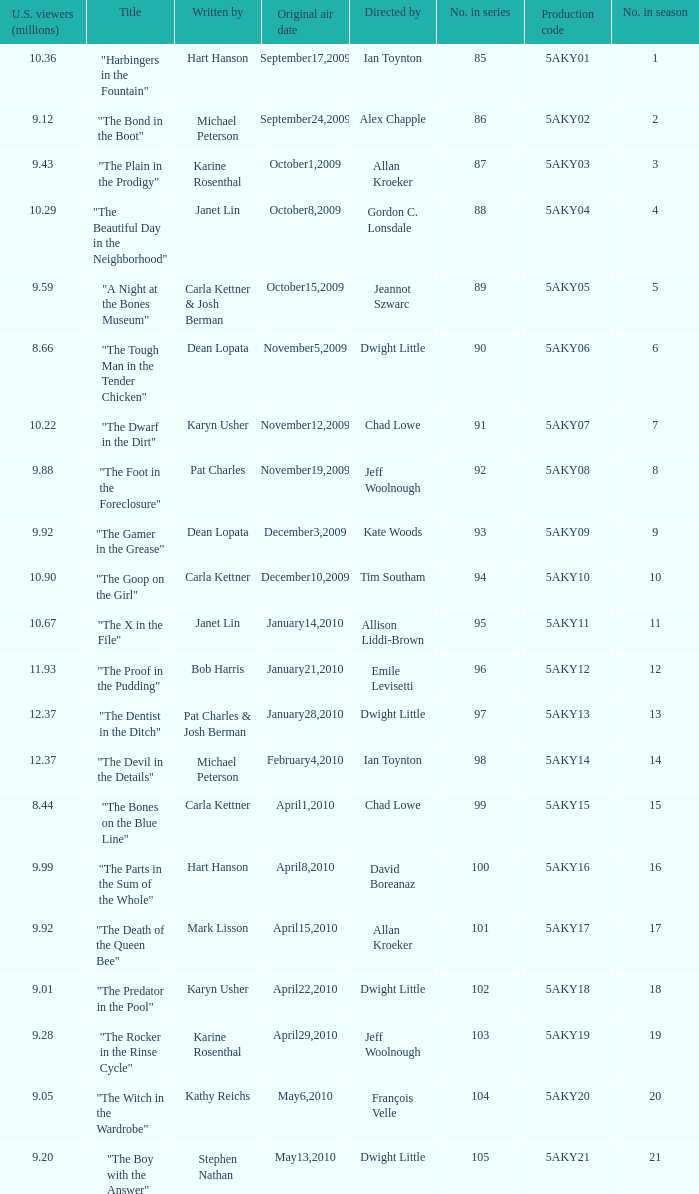What was the air date of the episode that has a production code of 5aky13? January28,2010. 